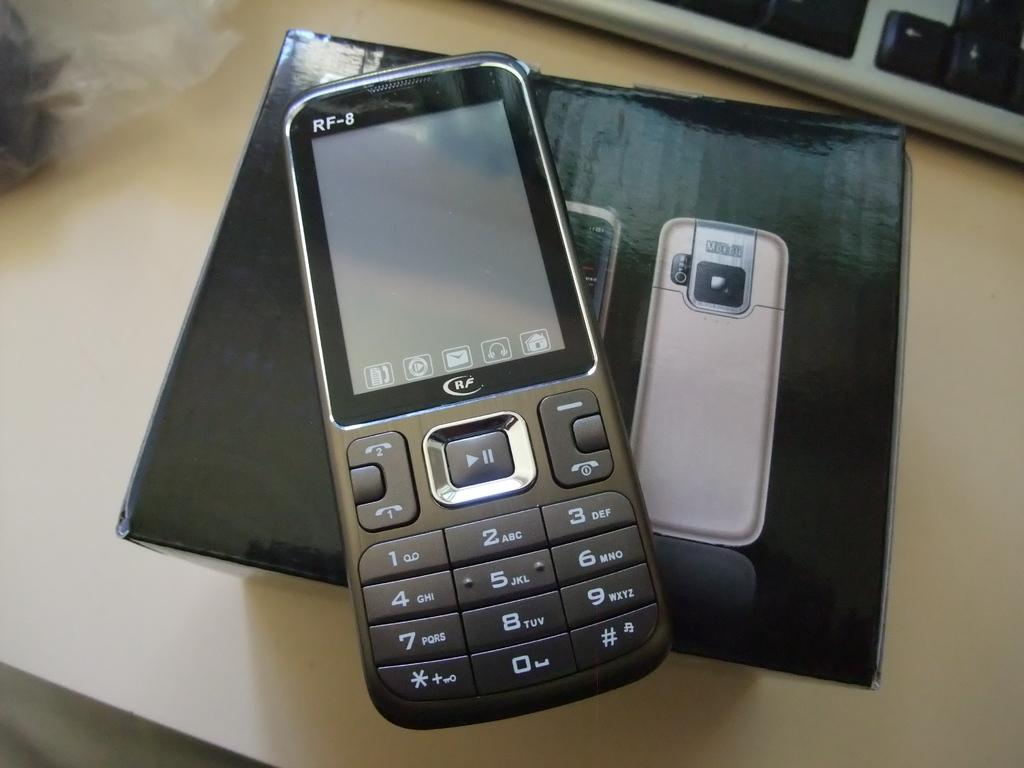<image>
Summarize the visual content of the image. A phone, model RF-8 is on but has a dark screen. 